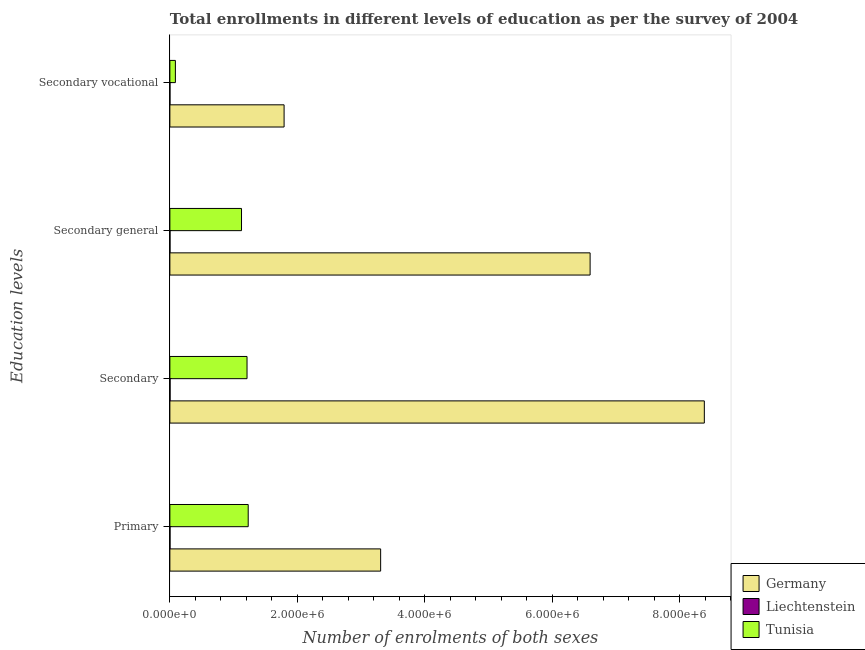How many groups of bars are there?
Make the answer very short. 4. How many bars are there on the 4th tick from the top?
Provide a succinct answer. 3. What is the label of the 1st group of bars from the top?
Provide a succinct answer. Secondary vocational. What is the number of enrolments in secondary vocational education in Tunisia?
Your response must be concise. 8.66e+04. Across all countries, what is the maximum number of enrolments in secondary education?
Offer a terse response. 8.38e+06. Across all countries, what is the minimum number of enrolments in secondary education?
Your answer should be very brief. 3273. In which country was the number of enrolments in primary education minimum?
Your answer should be compact. Liechtenstein. What is the total number of enrolments in primary education in the graph?
Provide a short and direct response. 4.54e+06. What is the difference between the number of enrolments in secondary vocational education in Tunisia and that in Germany?
Offer a very short reply. -1.70e+06. What is the difference between the number of enrolments in secondary general education in Germany and the number of enrolments in secondary vocational education in Liechtenstein?
Provide a succinct answer. 6.59e+06. What is the average number of enrolments in primary education per country?
Your answer should be compact. 1.51e+06. What is the difference between the number of enrolments in secondary vocational education and number of enrolments in primary education in Germany?
Make the answer very short. -1.51e+06. In how many countries, is the number of enrolments in primary education greater than 400000 ?
Provide a succinct answer. 2. What is the ratio of the number of enrolments in secondary education in Germany to that in Tunisia?
Ensure brevity in your answer.  6.93. What is the difference between the highest and the second highest number of enrolments in primary education?
Keep it short and to the point. 2.08e+06. What is the difference between the highest and the lowest number of enrolments in secondary education?
Your response must be concise. 8.38e+06. In how many countries, is the number of enrolments in primary education greater than the average number of enrolments in primary education taken over all countries?
Your answer should be very brief. 1. Is it the case that in every country, the sum of the number of enrolments in secondary vocational education and number of enrolments in primary education is greater than the sum of number of enrolments in secondary general education and number of enrolments in secondary education?
Provide a succinct answer. No. What does the 2nd bar from the top in Secondary general represents?
Offer a terse response. Liechtenstein. What does the 3rd bar from the bottom in Secondary vocational represents?
Your response must be concise. Tunisia. Is it the case that in every country, the sum of the number of enrolments in primary education and number of enrolments in secondary education is greater than the number of enrolments in secondary general education?
Make the answer very short. Yes. How many countries are there in the graph?
Keep it short and to the point. 3. Does the graph contain any zero values?
Provide a succinct answer. No. Does the graph contain grids?
Your answer should be compact. No. Where does the legend appear in the graph?
Your response must be concise. Bottom right. How are the legend labels stacked?
Ensure brevity in your answer.  Vertical. What is the title of the graph?
Your answer should be compact. Total enrollments in different levels of education as per the survey of 2004. Does "Switzerland" appear as one of the legend labels in the graph?
Your answer should be compact. No. What is the label or title of the X-axis?
Ensure brevity in your answer.  Number of enrolments of both sexes. What is the label or title of the Y-axis?
Provide a short and direct response. Education levels. What is the Number of enrolments of both sexes of Germany in Primary?
Provide a succinct answer. 3.31e+06. What is the Number of enrolments of both sexes of Liechtenstein in Primary?
Offer a terse response. 2266. What is the Number of enrolments of both sexes in Tunisia in Primary?
Your answer should be very brief. 1.23e+06. What is the Number of enrolments of both sexes of Germany in Secondary?
Offer a terse response. 8.38e+06. What is the Number of enrolments of both sexes of Liechtenstein in Secondary?
Your answer should be very brief. 3273. What is the Number of enrolments of both sexes in Tunisia in Secondary?
Offer a terse response. 1.21e+06. What is the Number of enrolments of both sexes of Germany in Secondary general?
Give a very brief answer. 6.59e+06. What is the Number of enrolments of both sexes of Liechtenstein in Secondary general?
Offer a terse response. 1975. What is the Number of enrolments of both sexes of Tunisia in Secondary general?
Give a very brief answer. 1.12e+06. What is the Number of enrolments of both sexes of Germany in Secondary vocational?
Your response must be concise. 1.79e+06. What is the Number of enrolments of both sexes in Liechtenstein in Secondary vocational?
Ensure brevity in your answer.  1171. What is the Number of enrolments of both sexes in Tunisia in Secondary vocational?
Provide a succinct answer. 8.66e+04. Across all Education levels, what is the maximum Number of enrolments of both sexes of Germany?
Your answer should be very brief. 8.38e+06. Across all Education levels, what is the maximum Number of enrolments of both sexes in Liechtenstein?
Provide a short and direct response. 3273. Across all Education levels, what is the maximum Number of enrolments of both sexes of Tunisia?
Your response must be concise. 1.23e+06. Across all Education levels, what is the minimum Number of enrolments of both sexes in Germany?
Provide a short and direct response. 1.79e+06. Across all Education levels, what is the minimum Number of enrolments of both sexes in Liechtenstein?
Provide a short and direct response. 1171. Across all Education levels, what is the minimum Number of enrolments of both sexes in Tunisia?
Your response must be concise. 8.66e+04. What is the total Number of enrolments of both sexes in Germany in the graph?
Provide a short and direct response. 2.01e+07. What is the total Number of enrolments of both sexes in Liechtenstein in the graph?
Your answer should be compact. 8685. What is the total Number of enrolments of both sexes in Tunisia in the graph?
Your answer should be compact. 3.65e+06. What is the difference between the Number of enrolments of both sexes in Germany in Primary and that in Secondary?
Your answer should be very brief. -5.08e+06. What is the difference between the Number of enrolments of both sexes of Liechtenstein in Primary and that in Secondary?
Make the answer very short. -1007. What is the difference between the Number of enrolments of both sexes in Tunisia in Primary and that in Secondary?
Ensure brevity in your answer.  1.83e+04. What is the difference between the Number of enrolments of both sexes in Germany in Primary and that in Secondary general?
Offer a terse response. -3.29e+06. What is the difference between the Number of enrolments of both sexes in Liechtenstein in Primary and that in Secondary general?
Your answer should be compact. 291. What is the difference between the Number of enrolments of both sexes of Tunisia in Primary and that in Secondary general?
Offer a terse response. 1.05e+05. What is the difference between the Number of enrolments of both sexes of Germany in Primary and that in Secondary vocational?
Your answer should be compact. 1.51e+06. What is the difference between the Number of enrolments of both sexes of Liechtenstein in Primary and that in Secondary vocational?
Provide a short and direct response. 1095. What is the difference between the Number of enrolments of both sexes of Tunisia in Primary and that in Secondary vocational?
Ensure brevity in your answer.  1.14e+06. What is the difference between the Number of enrolments of both sexes of Germany in Secondary and that in Secondary general?
Your response must be concise. 1.79e+06. What is the difference between the Number of enrolments of both sexes in Liechtenstein in Secondary and that in Secondary general?
Keep it short and to the point. 1298. What is the difference between the Number of enrolments of both sexes of Tunisia in Secondary and that in Secondary general?
Provide a succinct answer. 8.66e+04. What is the difference between the Number of enrolments of both sexes in Germany in Secondary and that in Secondary vocational?
Give a very brief answer. 6.59e+06. What is the difference between the Number of enrolments of both sexes of Liechtenstein in Secondary and that in Secondary vocational?
Provide a short and direct response. 2102. What is the difference between the Number of enrolments of both sexes in Tunisia in Secondary and that in Secondary vocational?
Make the answer very short. 1.12e+06. What is the difference between the Number of enrolments of both sexes of Germany in Secondary general and that in Secondary vocational?
Offer a very short reply. 4.80e+06. What is the difference between the Number of enrolments of both sexes in Liechtenstein in Secondary general and that in Secondary vocational?
Provide a short and direct response. 804. What is the difference between the Number of enrolments of both sexes in Tunisia in Secondary general and that in Secondary vocational?
Ensure brevity in your answer.  1.04e+06. What is the difference between the Number of enrolments of both sexes of Germany in Primary and the Number of enrolments of both sexes of Liechtenstein in Secondary?
Your answer should be very brief. 3.30e+06. What is the difference between the Number of enrolments of both sexes of Germany in Primary and the Number of enrolments of both sexes of Tunisia in Secondary?
Your answer should be compact. 2.10e+06. What is the difference between the Number of enrolments of both sexes of Liechtenstein in Primary and the Number of enrolments of both sexes of Tunisia in Secondary?
Keep it short and to the point. -1.21e+06. What is the difference between the Number of enrolments of both sexes of Germany in Primary and the Number of enrolments of both sexes of Liechtenstein in Secondary general?
Offer a terse response. 3.30e+06. What is the difference between the Number of enrolments of both sexes in Germany in Primary and the Number of enrolments of both sexes in Tunisia in Secondary general?
Offer a terse response. 2.18e+06. What is the difference between the Number of enrolments of both sexes of Liechtenstein in Primary and the Number of enrolments of both sexes of Tunisia in Secondary general?
Your answer should be compact. -1.12e+06. What is the difference between the Number of enrolments of both sexes in Germany in Primary and the Number of enrolments of both sexes in Liechtenstein in Secondary vocational?
Your answer should be compact. 3.30e+06. What is the difference between the Number of enrolments of both sexes in Germany in Primary and the Number of enrolments of both sexes in Tunisia in Secondary vocational?
Give a very brief answer. 3.22e+06. What is the difference between the Number of enrolments of both sexes in Liechtenstein in Primary and the Number of enrolments of both sexes in Tunisia in Secondary vocational?
Ensure brevity in your answer.  -8.43e+04. What is the difference between the Number of enrolments of both sexes in Germany in Secondary and the Number of enrolments of both sexes in Liechtenstein in Secondary general?
Give a very brief answer. 8.38e+06. What is the difference between the Number of enrolments of both sexes in Germany in Secondary and the Number of enrolments of both sexes in Tunisia in Secondary general?
Offer a very short reply. 7.26e+06. What is the difference between the Number of enrolments of both sexes in Liechtenstein in Secondary and the Number of enrolments of both sexes in Tunisia in Secondary general?
Make the answer very short. -1.12e+06. What is the difference between the Number of enrolments of both sexes of Germany in Secondary and the Number of enrolments of both sexes of Liechtenstein in Secondary vocational?
Your answer should be compact. 8.38e+06. What is the difference between the Number of enrolments of both sexes of Germany in Secondary and the Number of enrolments of both sexes of Tunisia in Secondary vocational?
Provide a short and direct response. 8.30e+06. What is the difference between the Number of enrolments of both sexes of Liechtenstein in Secondary and the Number of enrolments of both sexes of Tunisia in Secondary vocational?
Give a very brief answer. -8.33e+04. What is the difference between the Number of enrolments of both sexes in Germany in Secondary general and the Number of enrolments of both sexes in Liechtenstein in Secondary vocational?
Provide a short and direct response. 6.59e+06. What is the difference between the Number of enrolments of both sexes of Germany in Secondary general and the Number of enrolments of both sexes of Tunisia in Secondary vocational?
Give a very brief answer. 6.50e+06. What is the difference between the Number of enrolments of both sexes of Liechtenstein in Secondary general and the Number of enrolments of both sexes of Tunisia in Secondary vocational?
Ensure brevity in your answer.  -8.46e+04. What is the average Number of enrolments of both sexes of Germany per Education levels?
Give a very brief answer. 5.02e+06. What is the average Number of enrolments of both sexes in Liechtenstein per Education levels?
Provide a succinct answer. 2171.25. What is the average Number of enrolments of both sexes in Tunisia per Education levels?
Your answer should be very brief. 9.12e+05. What is the difference between the Number of enrolments of both sexes in Germany and Number of enrolments of both sexes in Liechtenstein in Primary?
Your response must be concise. 3.30e+06. What is the difference between the Number of enrolments of both sexes in Germany and Number of enrolments of both sexes in Tunisia in Primary?
Your answer should be compact. 2.08e+06. What is the difference between the Number of enrolments of both sexes of Liechtenstein and Number of enrolments of both sexes of Tunisia in Primary?
Your response must be concise. -1.23e+06. What is the difference between the Number of enrolments of both sexes of Germany and Number of enrolments of both sexes of Liechtenstein in Secondary?
Provide a short and direct response. 8.38e+06. What is the difference between the Number of enrolments of both sexes in Germany and Number of enrolments of both sexes in Tunisia in Secondary?
Provide a short and direct response. 7.17e+06. What is the difference between the Number of enrolments of both sexes of Liechtenstein and Number of enrolments of both sexes of Tunisia in Secondary?
Make the answer very short. -1.21e+06. What is the difference between the Number of enrolments of both sexes in Germany and Number of enrolments of both sexes in Liechtenstein in Secondary general?
Offer a terse response. 6.59e+06. What is the difference between the Number of enrolments of both sexes of Germany and Number of enrolments of both sexes of Tunisia in Secondary general?
Ensure brevity in your answer.  5.47e+06. What is the difference between the Number of enrolments of both sexes in Liechtenstein and Number of enrolments of both sexes in Tunisia in Secondary general?
Your answer should be compact. -1.12e+06. What is the difference between the Number of enrolments of both sexes of Germany and Number of enrolments of both sexes of Liechtenstein in Secondary vocational?
Your answer should be very brief. 1.79e+06. What is the difference between the Number of enrolments of both sexes of Germany and Number of enrolments of both sexes of Tunisia in Secondary vocational?
Provide a short and direct response. 1.70e+06. What is the difference between the Number of enrolments of both sexes in Liechtenstein and Number of enrolments of both sexes in Tunisia in Secondary vocational?
Offer a terse response. -8.54e+04. What is the ratio of the Number of enrolments of both sexes in Germany in Primary to that in Secondary?
Keep it short and to the point. 0.39. What is the ratio of the Number of enrolments of both sexes of Liechtenstein in Primary to that in Secondary?
Offer a terse response. 0.69. What is the ratio of the Number of enrolments of both sexes of Tunisia in Primary to that in Secondary?
Keep it short and to the point. 1.02. What is the ratio of the Number of enrolments of both sexes in Germany in Primary to that in Secondary general?
Provide a succinct answer. 0.5. What is the ratio of the Number of enrolments of both sexes in Liechtenstein in Primary to that in Secondary general?
Ensure brevity in your answer.  1.15. What is the ratio of the Number of enrolments of both sexes of Tunisia in Primary to that in Secondary general?
Ensure brevity in your answer.  1.09. What is the ratio of the Number of enrolments of both sexes in Germany in Primary to that in Secondary vocational?
Your answer should be very brief. 1.85. What is the ratio of the Number of enrolments of both sexes in Liechtenstein in Primary to that in Secondary vocational?
Make the answer very short. 1.94. What is the ratio of the Number of enrolments of both sexes in Tunisia in Primary to that in Secondary vocational?
Give a very brief answer. 14.18. What is the ratio of the Number of enrolments of both sexes in Germany in Secondary to that in Secondary general?
Provide a succinct answer. 1.27. What is the ratio of the Number of enrolments of both sexes in Liechtenstein in Secondary to that in Secondary general?
Offer a very short reply. 1.66. What is the ratio of the Number of enrolments of both sexes of Tunisia in Secondary to that in Secondary general?
Your answer should be compact. 1.08. What is the ratio of the Number of enrolments of both sexes in Germany in Secondary to that in Secondary vocational?
Provide a succinct answer. 4.68. What is the ratio of the Number of enrolments of both sexes in Liechtenstein in Secondary to that in Secondary vocational?
Your answer should be compact. 2.79. What is the ratio of the Number of enrolments of both sexes in Tunisia in Secondary to that in Secondary vocational?
Make the answer very short. 13.97. What is the ratio of the Number of enrolments of both sexes of Germany in Secondary general to that in Secondary vocational?
Keep it short and to the point. 3.68. What is the ratio of the Number of enrolments of both sexes of Liechtenstein in Secondary general to that in Secondary vocational?
Your response must be concise. 1.69. What is the ratio of the Number of enrolments of both sexes in Tunisia in Secondary general to that in Secondary vocational?
Your answer should be very brief. 12.97. What is the difference between the highest and the second highest Number of enrolments of both sexes of Germany?
Provide a short and direct response. 1.79e+06. What is the difference between the highest and the second highest Number of enrolments of both sexes of Liechtenstein?
Offer a very short reply. 1007. What is the difference between the highest and the second highest Number of enrolments of both sexes of Tunisia?
Offer a terse response. 1.83e+04. What is the difference between the highest and the lowest Number of enrolments of both sexes in Germany?
Your answer should be compact. 6.59e+06. What is the difference between the highest and the lowest Number of enrolments of both sexes of Liechtenstein?
Your answer should be very brief. 2102. What is the difference between the highest and the lowest Number of enrolments of both sexes in Tunisia?
Offer a very short reply. 1.14e+06. 